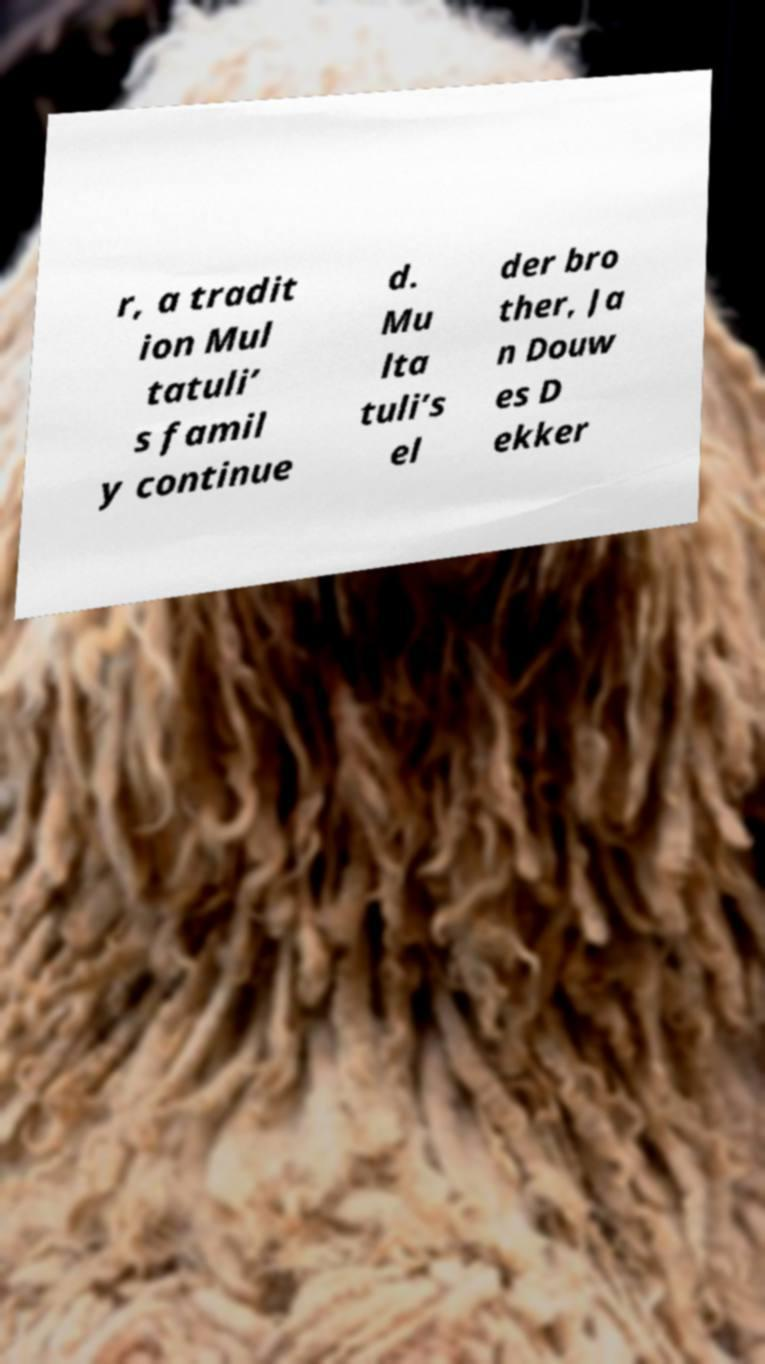Please read and relay the text visible in this image. What does it say? r, a tradit ion Mul tatuli’ s famil y continue d. Mu lta tuli’s el der bro ther, Ja n Douw es D ekker 